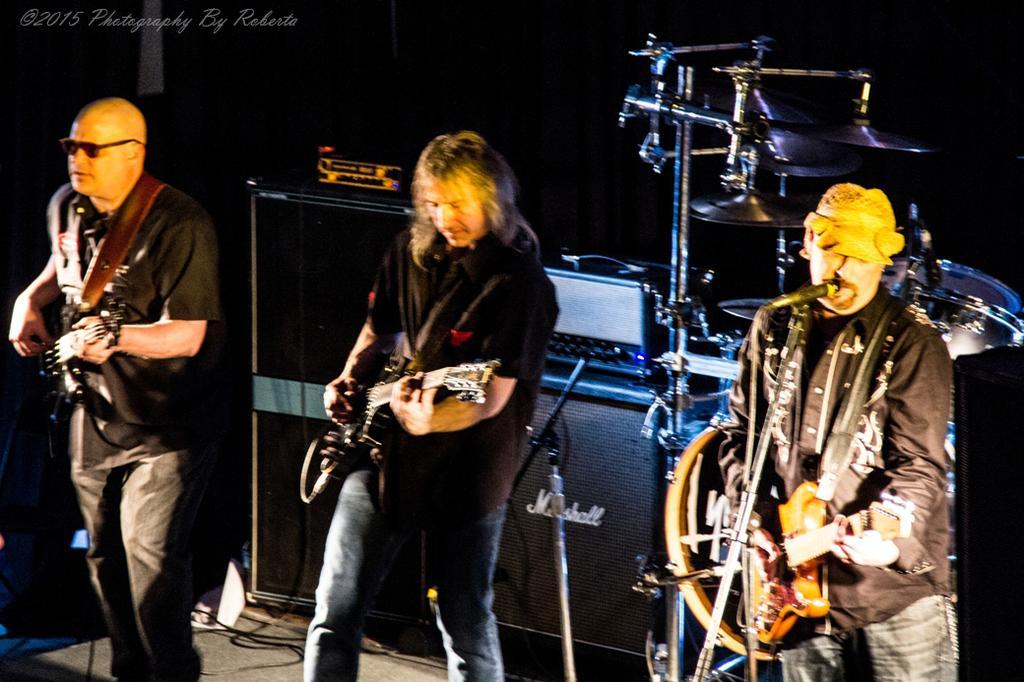In one or two sentences, can you explain what this image depicts? In this picture we can see three persons standing and playing guitar and here on right side person singing on mic and in background we can see speakers an it is dark. 